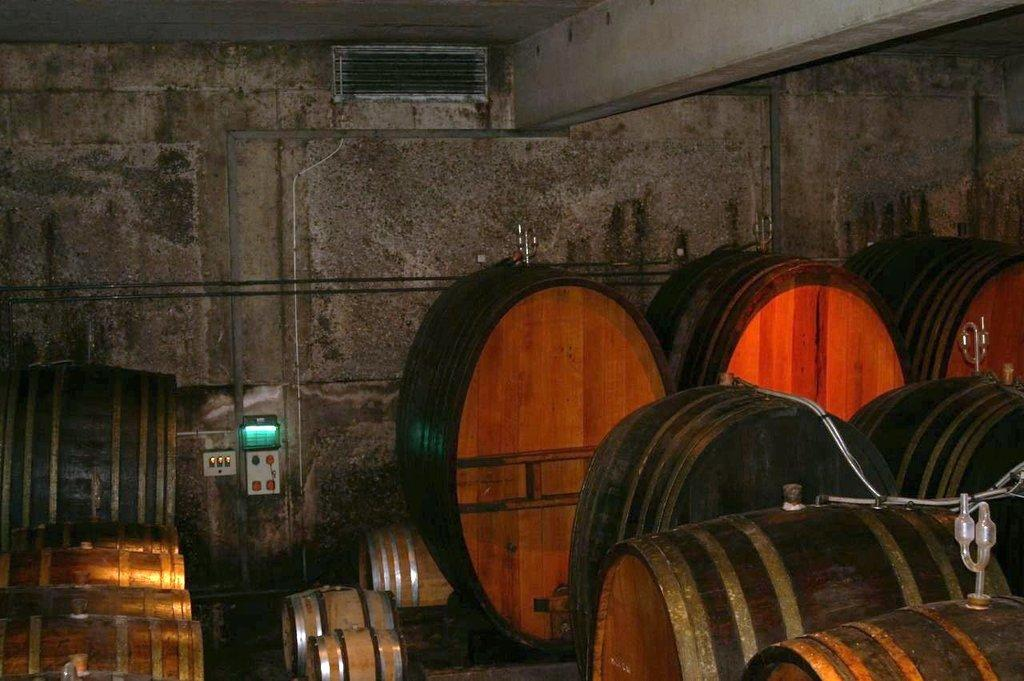What type of objects can be seen in the image? There are barrels in the image. What can be seen on the wall at the back? There are objects on the wall at the back. Can you describe the pipe on the wall? There is a pipe on the wall. What is located on the wall at the top? There is an object on the wall at the top. What type of stocking is hanging on the pipe in the image? There is no stocking present in the image; the pipe is the only object mentioned on the wall. 